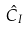Convert formula to latex. <formula><loc_0><loc_0><loc_500><loc_500>\hat { C } _ { I }</formula> 